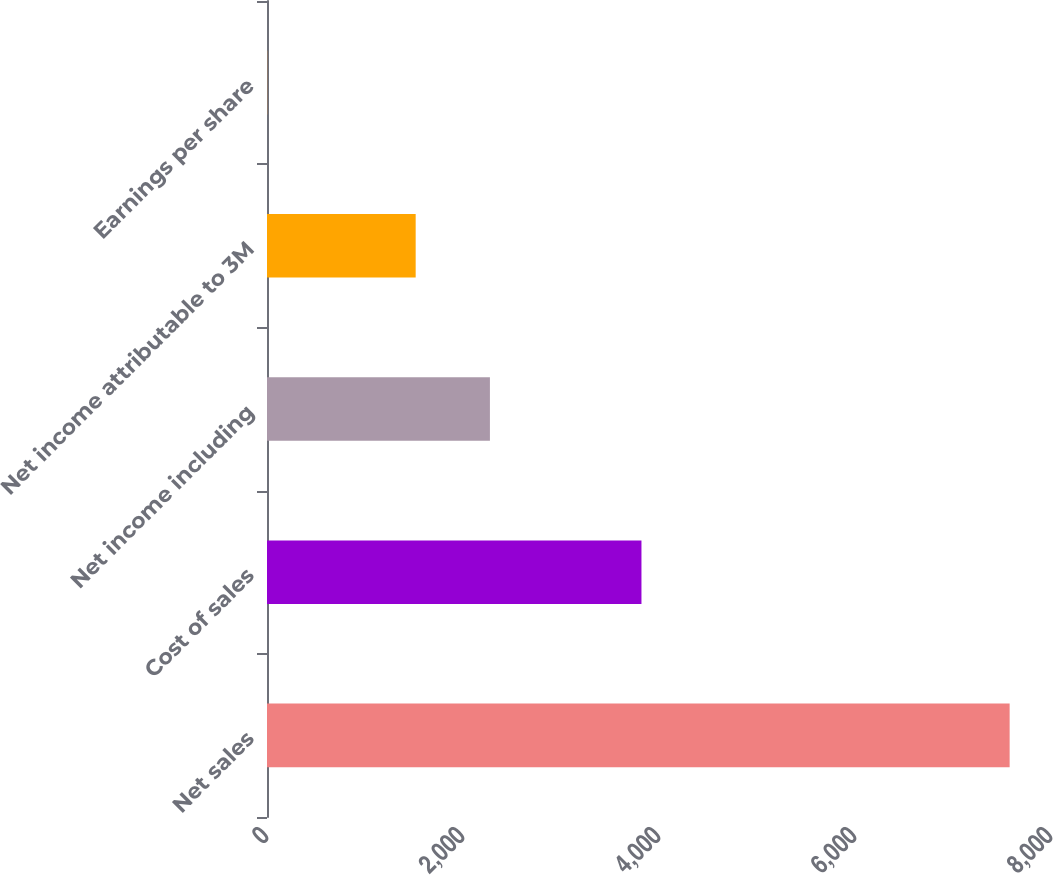Convert chart. <chart><loc_0><loc_0><loc_500><loc_500><bar_chart><fcel>Net sales<fcel>Cost of sales<fcel>Net income including<fcel>Net income attributable to 3M<fcel>Earnings per share<nl><fcel>7578<fcel>3821<fcel>2274.7<fcel>1517.09<fcel>1.85<nl></chart> 